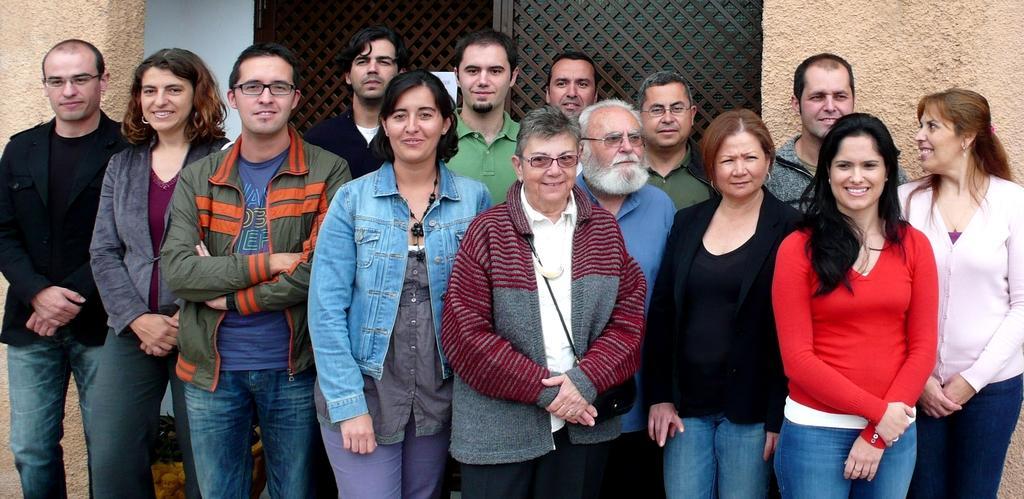Could you give a brief overview of what you see in this image? In the foreground of the picture there are group of people standing, they are smiling. In the center of the picture there is mesh. On the left and the right it is well. At the bottom there is a dustbin like object. 